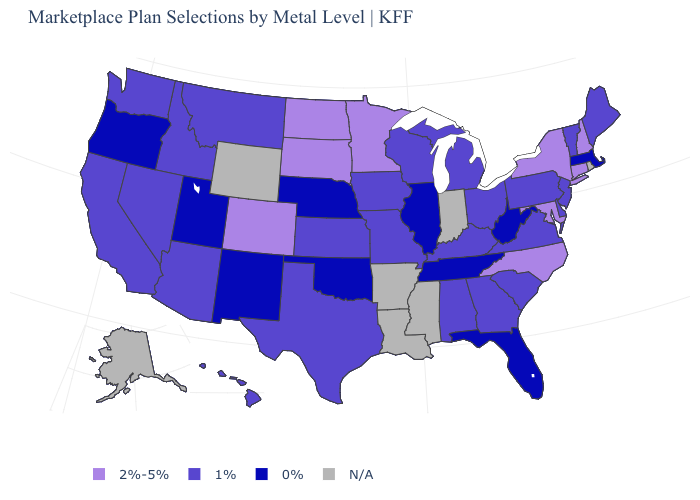Among the states that border Arizona , which have the highest value?
Answer briefly. Colorado. What is the value of South Carolina?
Concise answer only. 1%. Which states have the lowest value in the West?
Give a very brief answer. New Mexico, Oregon, Utah. What is the lowest value in the USA?
Concise answer only. 0%. Which states hav the highest value in the South?
Answer briefly. Maryland, North Carolina. Does Texas have the lowest value in the USA?
Concise answer only. No. Name the states that have a value in the range 0%?
Quick response, please. Florida, Illinois, Massachusetts, Nebraska, New Mexico, Oklahoma, Oregon, Tennessee, Utah, West Virginia. What is the value of Delaware?
Quick response, please. 1%. What is the highest value in the MidWest ?
Answer briefly. 2%-5%. Name the states that have a value in the range 2%-5%?
Write a very short answer. Colorado, Connecticut, Maryland, Minnesota, New Hampshire, New York, North Carolina, North Dakota, South Dakota. Among the states that border Rhode Island , does Connecticut have the lowest value?
Keep it brief. No. Which states hav the highest value in the West?
Be succinct. Colorado. Among the states that border Nevada , does Utah have the lowest value?
Quick response, please. Yes. Name the states that have a value in the range 0%?
Answer briefly. Florida, Illinois, Massachusetts, Nebraska, New Mexico, Oklahoma, Oregon, Tennessee, Utah, West Virginia. How many symbols are there in the legend?
Write a very short answer. 4. 